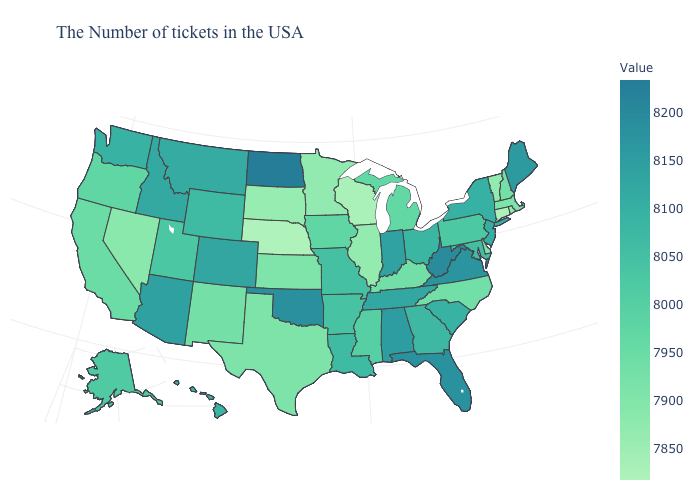Which states have the highest value in the USA?
Be succinct. North Dakota. Which states have the lowest value in the MidWest?
Concise answer only. Nebraska. Which states have the lowest value in the Northeast?
Short answer required. Connecticut. Does Minnesota have a higher value than Nebraska?
Quick response, please. Yes. Which states have the highest value in the USA?
Concise answer only. North Dakota. Which states hav the highest value in the MidWest?
Keep it brief. North Dakota. Does the map have missing data?
Give a very brief answer. No. Does North Dakota have the highest value in the USA?
Concise answer only. Yes. Does Alaska have a lower value than West Virginia?
Concise answer only. Yes. Does Pennsylvania have the lowest value in the USA?
Concise answer only. No. 